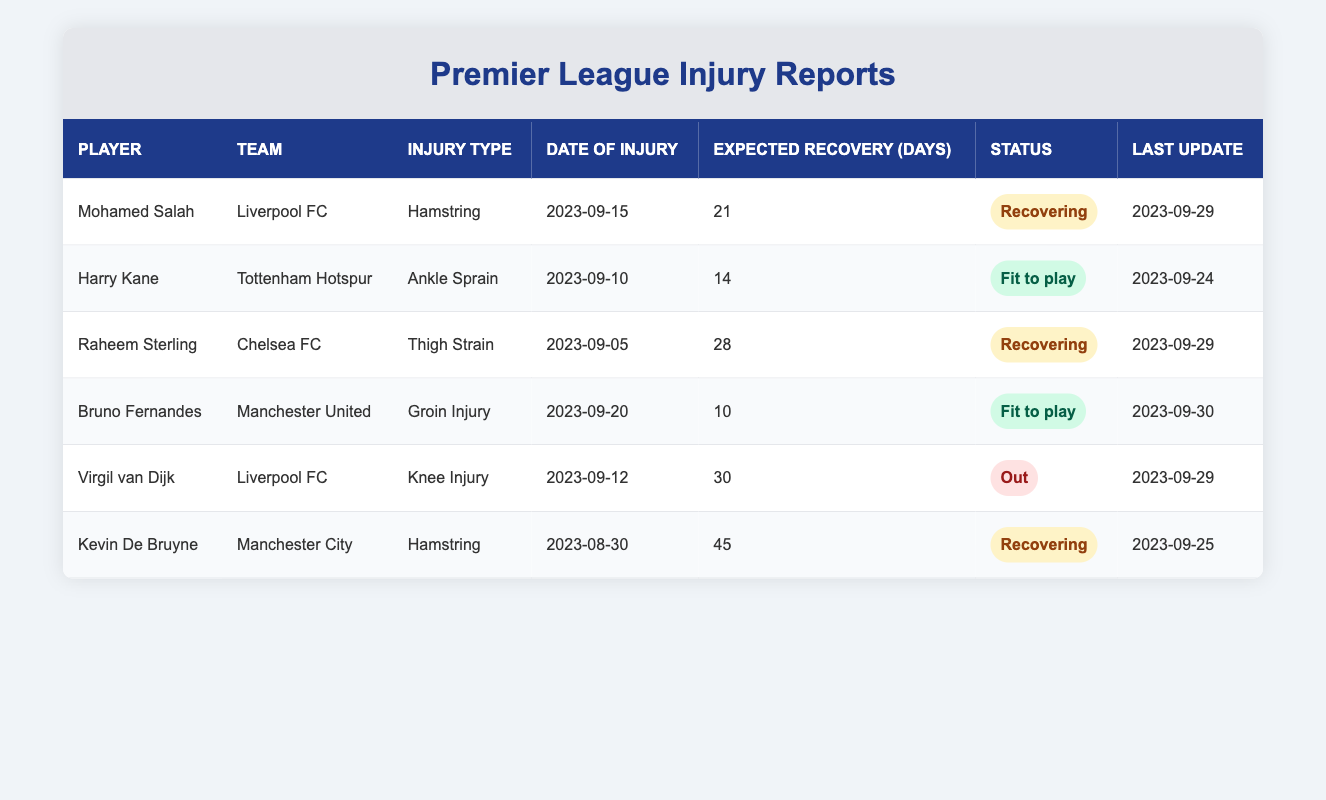What is the injury type for Mohamed Salah? Referring to the table, under the 'Injury Type' column for the row containing Mohamed Salah, the entry states "Hamstring."
Answer: Hamstring Which player from Liverpool FC is currently out due to an injury? In the table, the players from Liverpool FC are Mohamed Salah and Virgil van Dijk. Checking their statuses, Virgil van Dijk is marked as "Out," while Mohamed Salah is "Recovering."
Answer: Virgil van Dijk What is the expected recovery time for Raheem Sterling? The expected recovery time for Raheem Sterling is listed in the 'Expected Recovery (Days)' column, which shows "28."
Answer: 28 How many players are currently recovering from injuries? By scanning the statuses in the table, we find that Mohamed Salah, Raheem Sterling, and Kevin De Bruyne are marked as "Recovering," giving us a total of 3 players.
Answer: 3 Is Harry Kane fit to play after his injury? Looking at Harry Kane's status in the table, it states "Fit to play," confirming he has recovered and can participate.
Answer: Yes Which team has the most players listed as recovering and how many? The players recovering are Salah from Liverpool, Sterling from Chelsea, and De Bruyne from Manchester City. Liverpool has 1 player (Salah) and Chelsea has 1 player (Sterling), while Manchester City also has 1 player (De Bruyne). Therefore, the counts are equal; no team has more than others in this category.
Answer: No What is the average expected recovery time for all players listed? The expected recovery times are 21, 14, 28, 10, 30, and 45 days. Adding these values gives a total of 148 days. There are 6 players; hence average recovery time = 148/6 = 24.67, rounded to 25 days.
Answer: 25 days Which player has the longest expected recovery time and what is it? Reviewing the expected recovery times, Kevin De Bruyne at 45 days has the longest expected recovery time compared to the others, which are 21, 14, 28, 10, and 30 days.
Answer: 45 days What is the last update date for Bruno Fernandes? Observing the 'Last Update' column for Bruno Fernandes, it states "2023-09-30."
Answer: 2023-09-30 